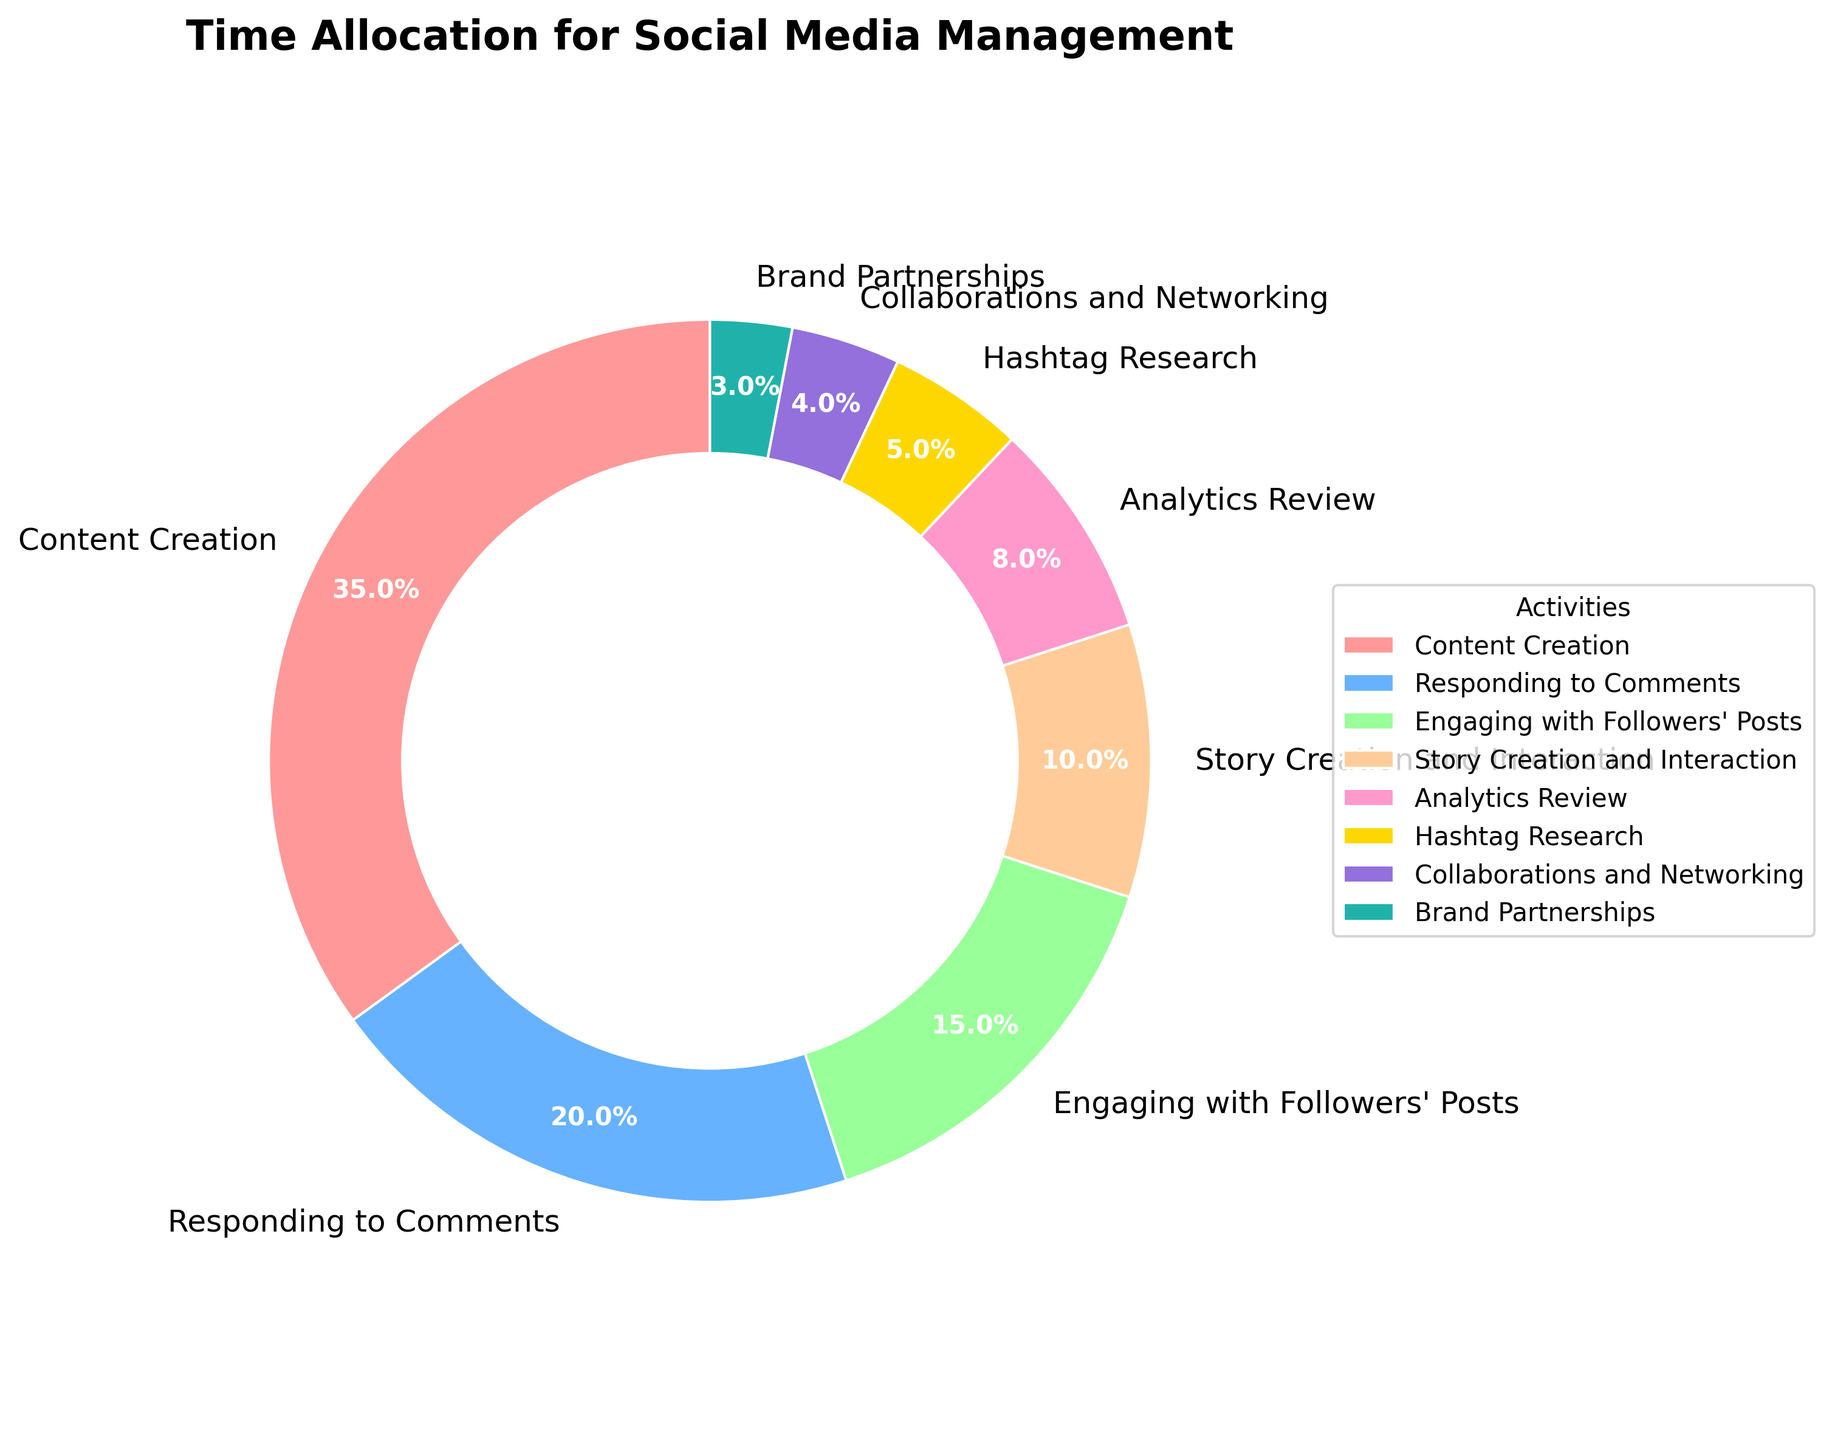What percentage of time is allocated to Content Creation? The pie chart shows the allocation of time for different activities. Content Creation is directly labeled with 35%.
Answer: 35% How much more time is spent on Responding to Comments compared to Hashtag Research? Responding to Comments is 20% and Hashtag Research is 5%. Subtracting 5% from 20% gives the additional time spent on Responding to Comments.
Answer: 15% Which activity takes up the least amount of time and what is its percentage? By examining the pie chart, Brand Partnerships has the smallest segment and is labeled as 3%.
Answer: Brand Partnerships, 3% What is the combined percentage of time spent on Story Creation and Interaction and Analytics Review? Story Creation and Interaction is 10% and Analytics Review is 8%. Adding these percentages gives the combined total.
Answer: 18% Is more time spent on Content Creation or on the combination of Engaging with Followers' Posts and Hashtag Research? Content Creation is 35%. Engaging with Followers' Posts is 15% and Hashtag Research is 5%. Adding 15% and 5% gives 20%. Since 35% is greater than 20%, more time is spent on Content Creation.
Answer: Content Creation Which activity group takes more than 20% of the total time? By inspecting the pie chart, only Content Creation (35%) exceeds 20%.
Answer: Content Creation Among the listed activities, which color represents the Analytics Review section? Viewing the colored segments, the Analytics Review section is indicated by a specific color.
Answer: Yellow What is the total percentage of time spent on activities related to engagement (Responding to Comments and Engaging with Followers' Posts)? Responding to Comments is 20% and Engaging with Followers' Posts is 15%. Adding these percentages gives 35%.
Answer: 35% Find the difference in time allocation between the activity with the highest percentage and the activity with the lowest percentage. The highest is Content Creation at 35% and the lowest is Brand Partnerships at 3%. Subtracting 3% from 35% gives the difference.
Answer: 32% 